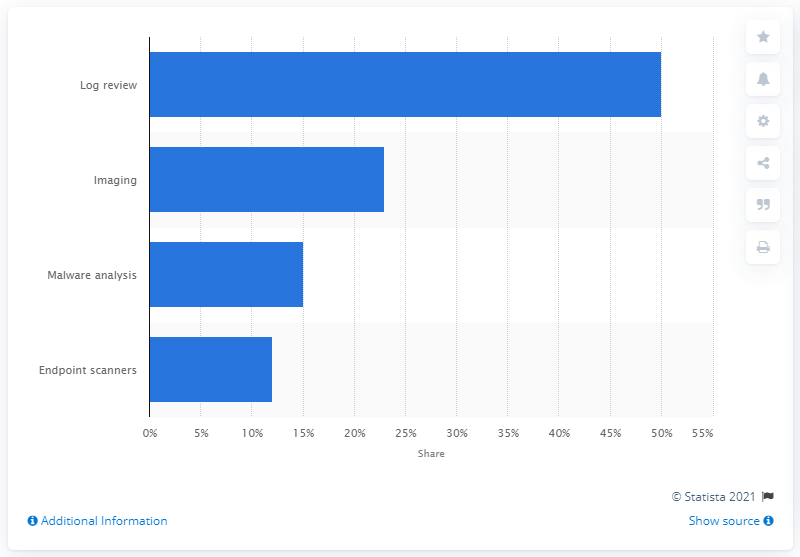Highlight a few significant elements in this photo. Malware analysis was used in 15% of investigations. 